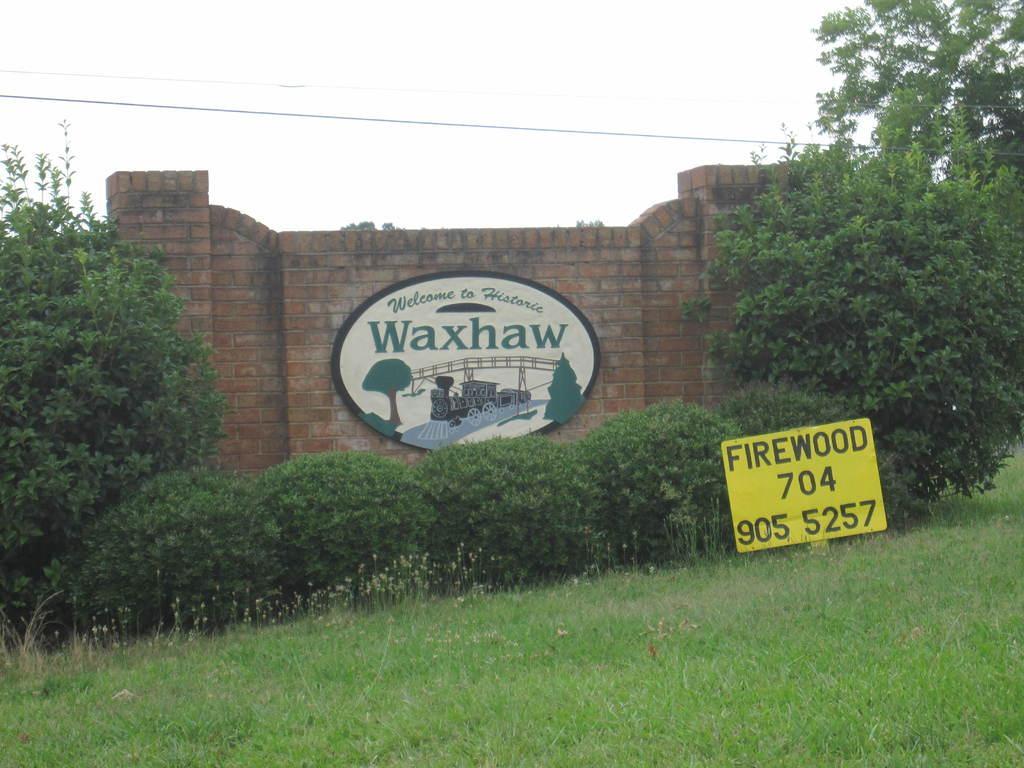In one or two sentences, can you explain what this image depicts? In this picture I can see trees, plants, grass and yellow color board on which something written on it. Here I can see a wall which has something attached to it. In the background I can see the sky and wires. 